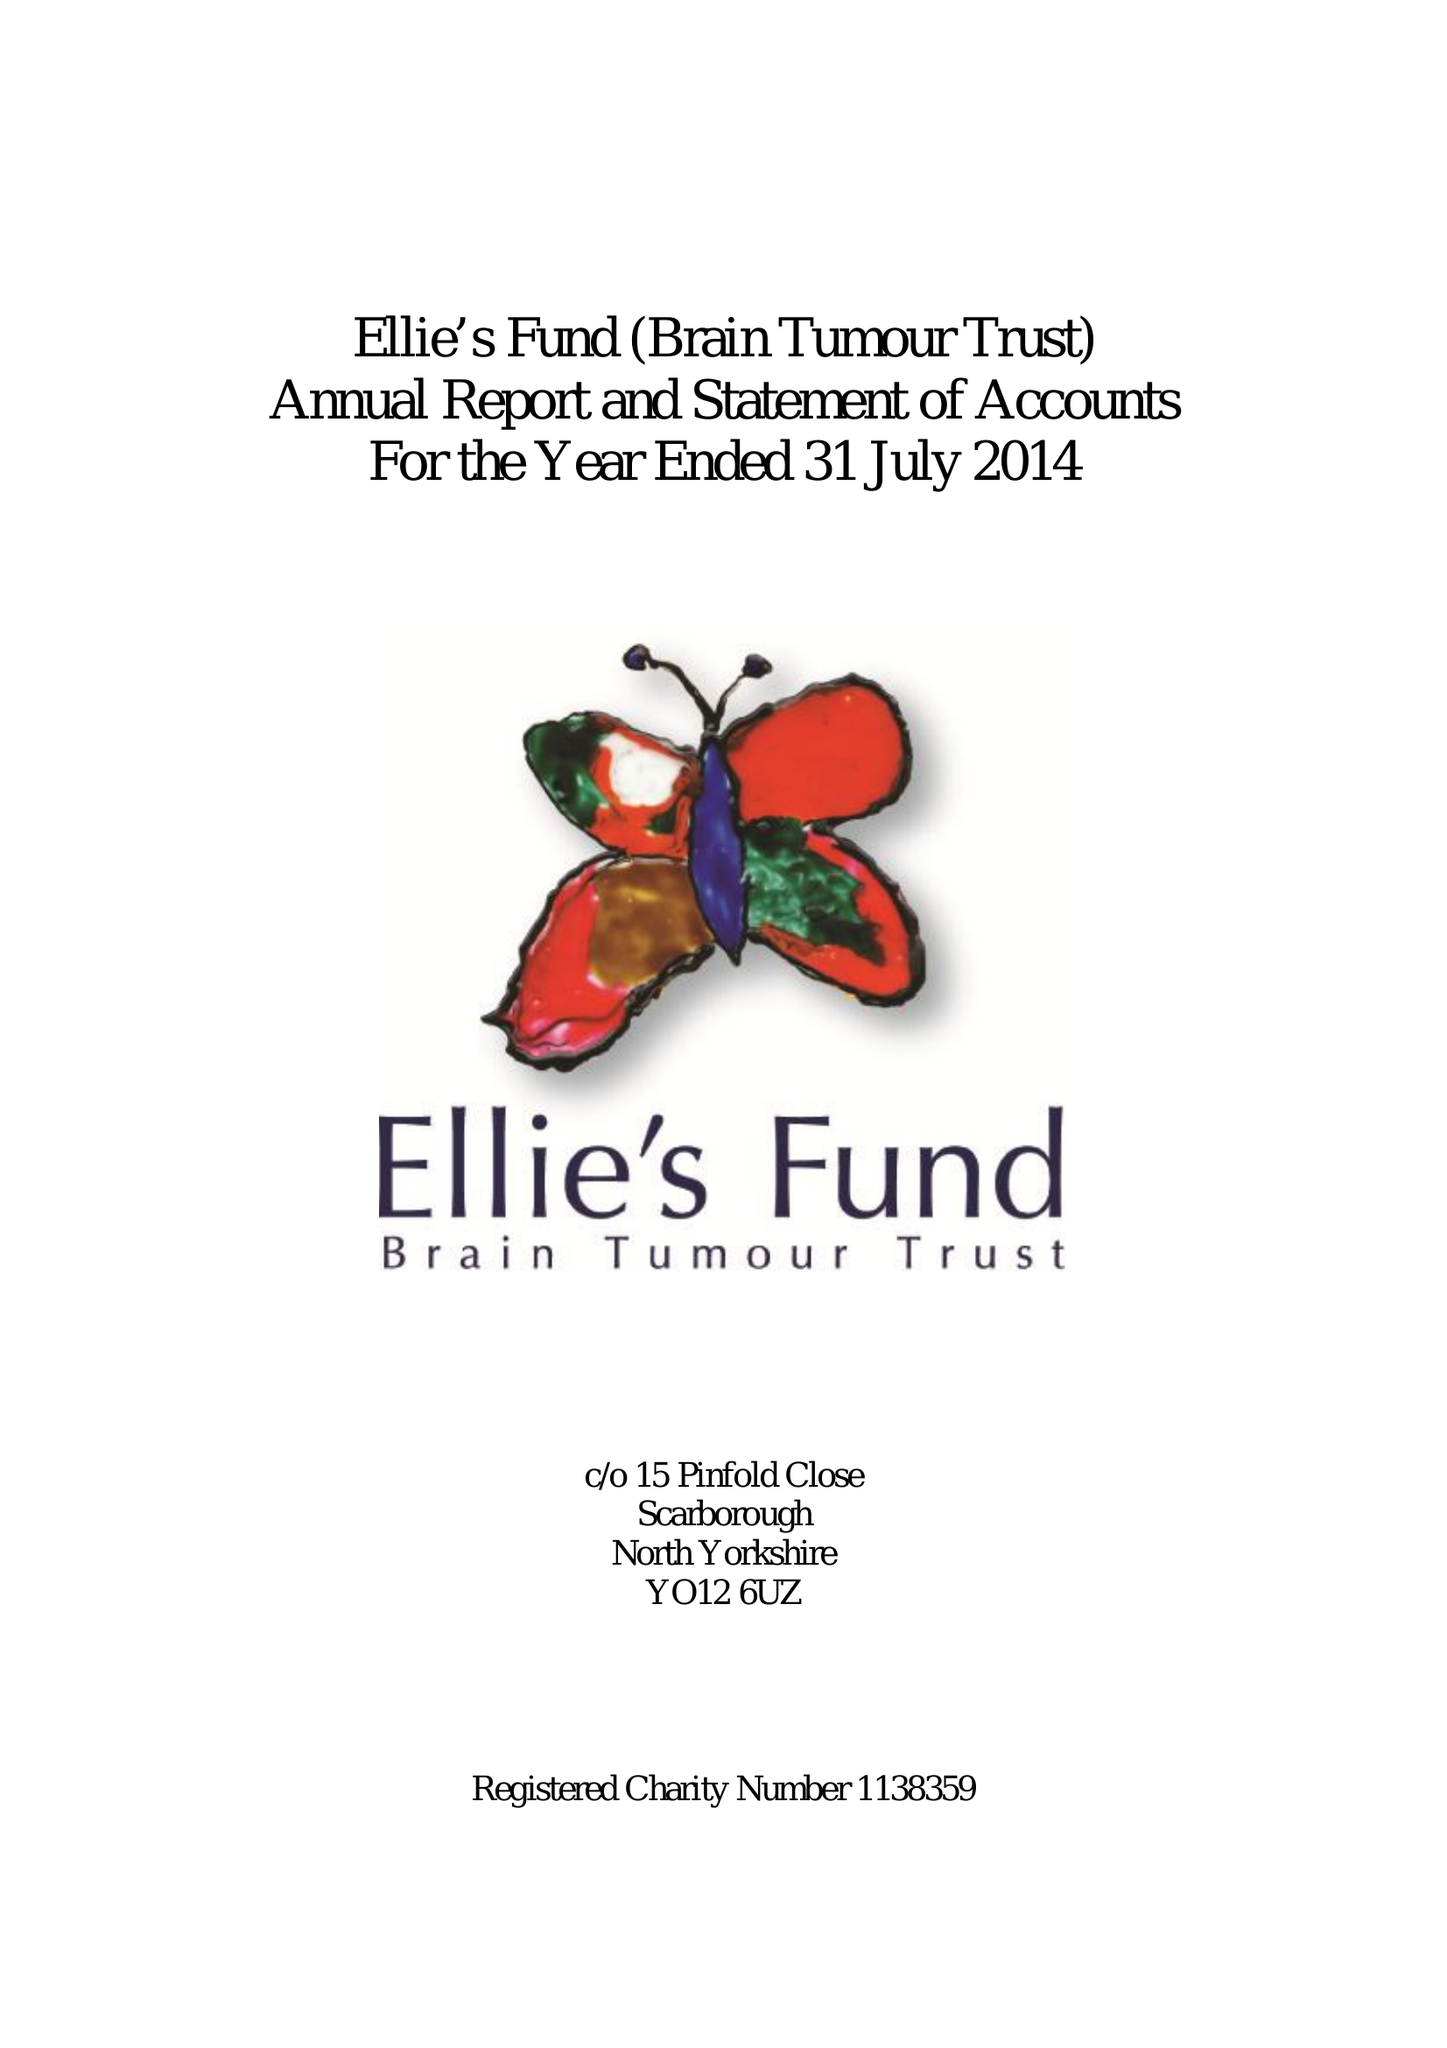What is the value for the address__post_town?
Answer the question using a single word or phrase. None 